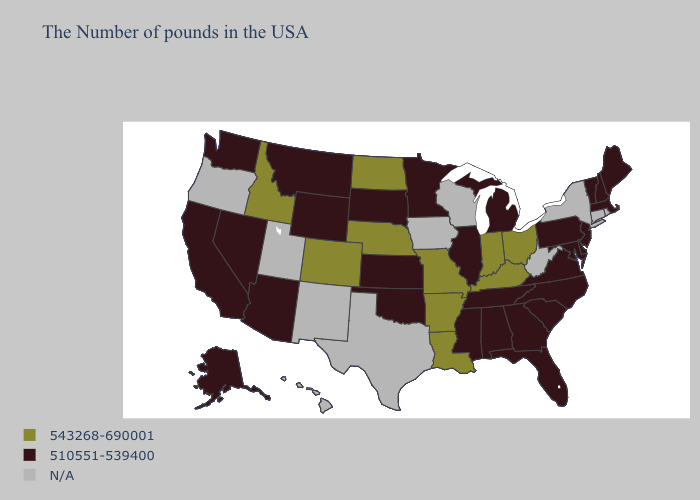Among the states that border Idaho , which have the highest value?
Give a very brief answer. Wyoming, Montana, Nevada, Washington. What is the lowest value in states that border Georgia?
Give a very brief answer. 510551-539400. What is the value of Connecticut?
Keep it brief. N/A. Which states hav the highest value in the West?
Short answer required. Colorado, Idaho. How many symbols are there in the legend?
Give a very brief answer. 3. What is the value of Alabama?
Short answer required. 510551-539400. Among the states that border New Mexico , does Oklahoma have the highest value?
Short answer required. No. Which states have the lowest value in the USA?
Concise answer only. Maine, Massachusetts, New Hampshire, Vermont, New Jersey, Delaware, Maryland, Pennsylvania, Virginia, North Carolina, South Carolina, Florida, Georgia, Michigan, Alabama, Tennessee, Illinois, Mississippi, Minnesota, Kansas, Oklahoma, South Dakota, Wyoming, Montana, Arizona, Nevada, California, Washington, Alaska. Name the states that have a value in the range 510551-539400?
Write a very short answer. Maine, Massachusetts, New Hampshire, Vermont, New Jersey, Delaware, Maryland, Pennsylvania, Virginia, North Carolina, South Carolina, Florida, Georgia, Michigan, Alabama, Tennessee, Illinois, Mississippi, Minnesota, Kansas, Oklahoma, South Dakota, Wyoming, Montana, Arizona, Nevada, California, Washington, Alaska. Which states have the lowest value in the USA?
Give a very brief answer. Maine, Massachusetts, New Hampshire, Vermont, New Jersey, Delaware, Maryland, Pennsylvania, Virginia, North Carolina, South Carolina, Florida, Georgia, Michigan, Alabama, Tennessee, Illinois, Mississippi, Minnesota, Kansas, Oklahoma, South Dakota, Wyoming, Montana, Arizona, Nevada, California, Washington, Alaska. Does the first symbol in the legend represent the smallest category?
Be succinct. No. What is the value of Arkansas?
Write a very short answer. 543268-690001. 